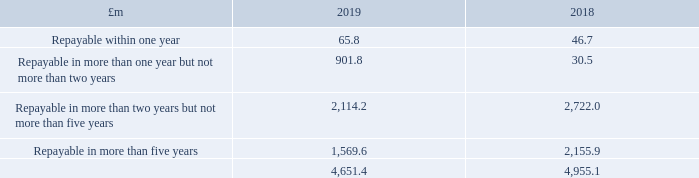23 Borrowings (continued)
The fair values of fixed rate borrowings and CMBS are assessed based on quoted market prices, and as such are categorised as Level 1 in the fair value hierarchy (see note 27 for definition). The fair values of unlisted floating rate borrowings are equal to their carrying values and are categorised as Level 2 in the fair value hierarchy.
The maturity profile of debt (excluding lease liabilities) is as follows:
Certain borrowing agreements contain financial and other conditions that, if contravened, could alter the repayment profile (further information is provided in financial covenants on pages 165 and 166)
At 31 December 2019 the Group had committed undrawn borrowing facilities of £238.5 million (2018: £274.2 million), maturing in 2021 and 2022. This includes £42.1 million of undrawn facilities in respect of development finance.
What is the amount of undrawn borrowing facilities at 31 December 2019? £238.5 million. What is the amount of undrawn facilities in respect of development finance? £42.1 million. What is the amount of debt repayable within one year in 2019?
Answer scale should be: million. 65.8. In which year is there a greater total debt? Find the year with the greater debt amount
Answer: 2018. In which year is there a greater debt repayable in more than five years? Find the year with the greater debt repayable in more than five years
Answer: 2018. What is the percentage change in the total debt from 2018 to 2019?
Answer scale should be: percent. (4,651.4-4,955.1)/4,955.1
Answer: -6.13. 